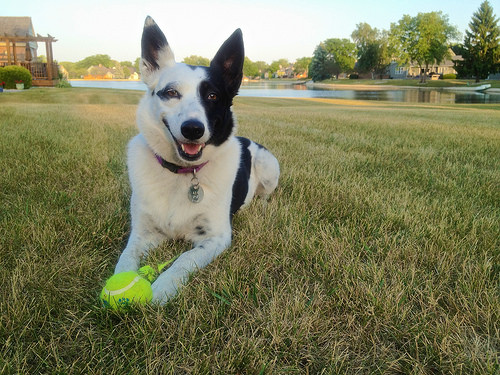<image>
Is the dog under the under? No. The dog is not positioned under the under. The vertical relationship between these objects is different. Is the dog behind the ball? Yes. From this viewpoint, the dog is positioned behind the ball, with the ball partially or fully occluding the dog. Is there a ball in front of the dog? Yes. The ball is positioned in front of the dog, appearing closer to the camera viewpoint. 